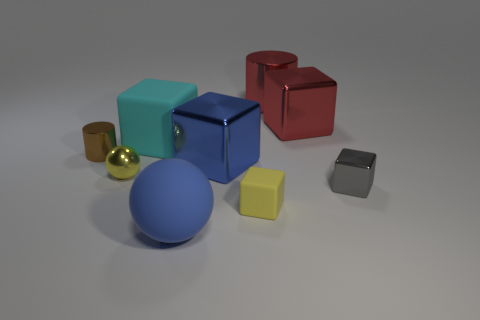There is a small shiny thing that is to the right of the large cyan cube; is it the same shape as the small yellow object that is behind the tiny gray shiny object?
Your response must be concise. No. How many other objects are the same material as the gray block?
Offer a very short reply. 5. Does the tiny cube in front of the gray metal block have the same material as the big object that is in front of the small gray metallic cube?
Offer a terse response. Yes. What shape is the other big thing that is made of the same material as the cyan object?
Your response must be concise. Sphere. Are there any other things that have the same color as the big sphere?
Give a very brief answer. Yes. What number of metal things are there?
Keep it short and to the point. 6. What shape is the small shiny object that is both to the right of the small brown metal cylinder and on the left side of the large red cube?
Provide a succinct answer. Sphere. What shape is the rubber thing that is right of the large block in front of the cube that is left of the large rubber sphere?
Offer a terse response. Cube. What is the material of the large block that is on the right side of the cyan rubber block and in front of the red metal block?
Offer a very short reply. Metal. What number of red objects are the same size as the cyan rubber object?
Ensure brevity in your answer.  2. 